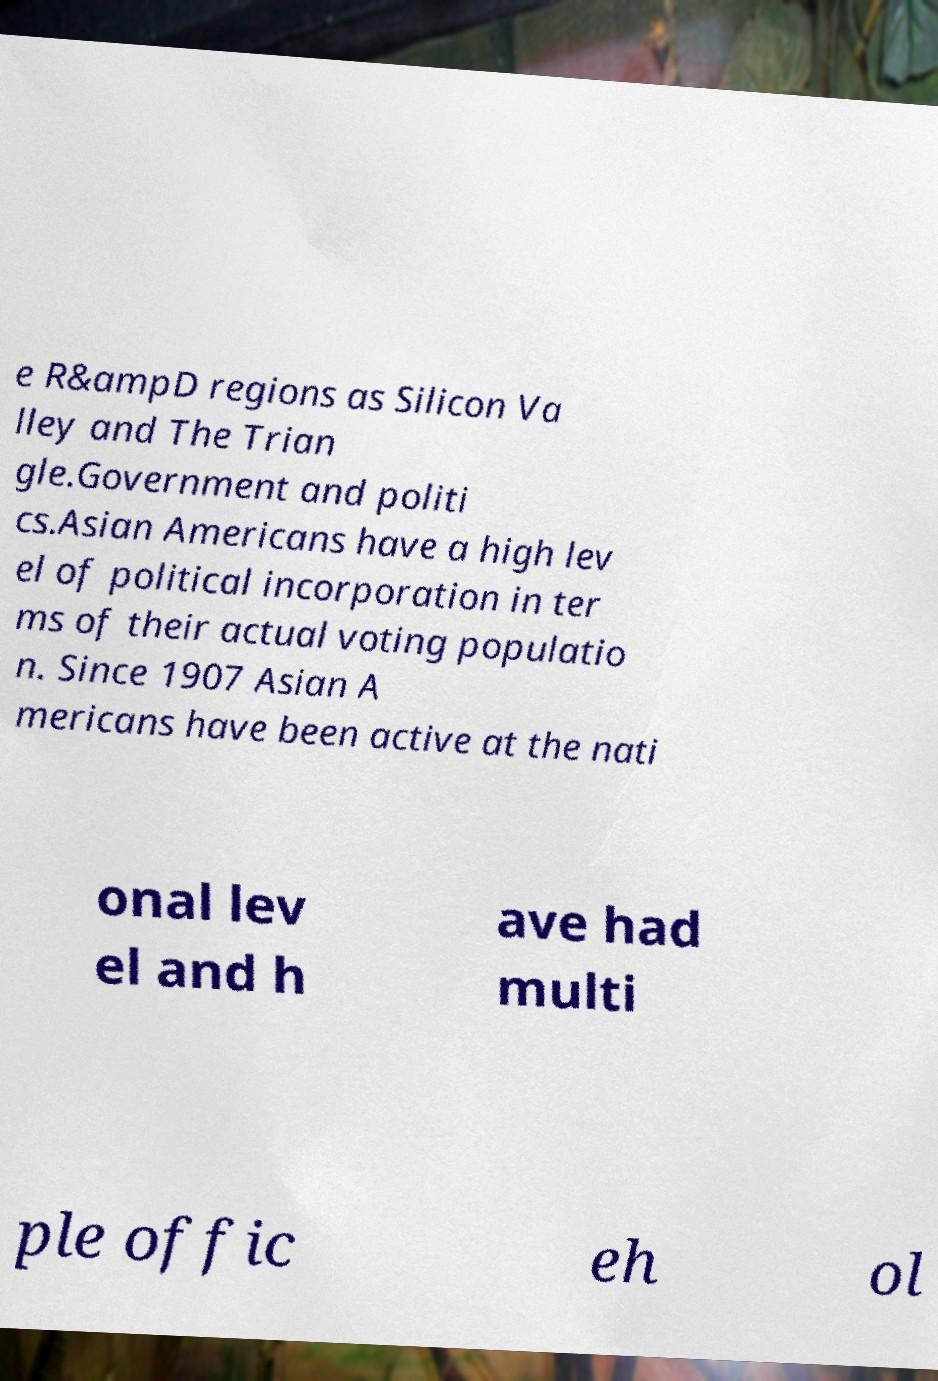I need the written content from this picture converted into text. Can you do that? e R&ampD regions as Silicon Va lley and The Trian gle.Government and politi cs.Asian Americans have a high lev el of political incorporation in ter ms of their actual voting populatio n. Since 1907 Asian A mericans have been active at the nati onal lev el and h ave had multi ple offic eh ol 